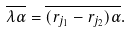Convert formula to latex. <formula><loc_0><loc_0><loc_500><loc_500>\overline { \lambda \alpha } = \overline { ( r _ { j _ { 1 } } - r _ { j _ { 2 } } ) \alpha } .</formula> 